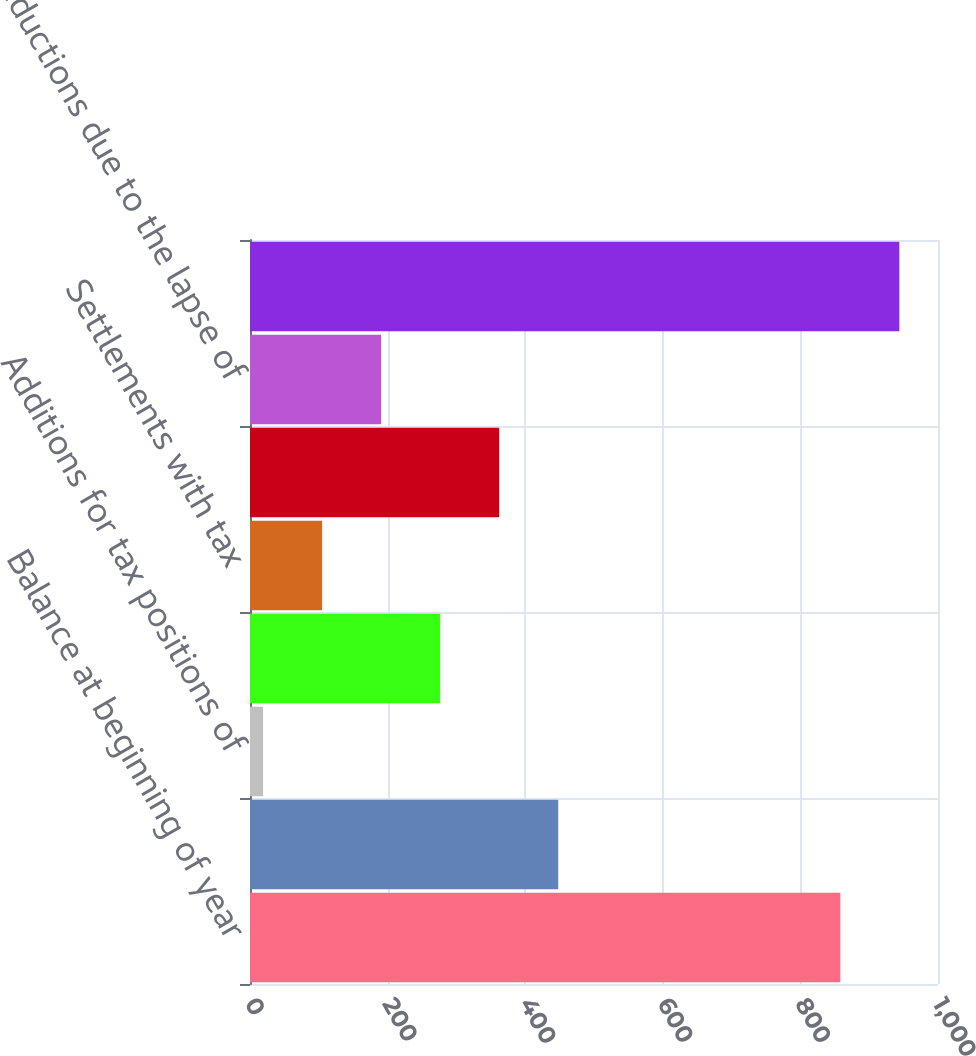Convert chart to OTSL. <chart><loc_0><loc_0><loc_500><loc_500><bar_chart><fcel>Balance at beginning of year<fcel>Additions based on tax<fcel>Additions for tax positions of<fcel>Impact of changes in exchange<fcel>Settlements with tax<fcel>Reductions for tax positions<fcel>Reductions due to the lapse of<fcel>Balance at end of year<nl><fcel>858<fcel>448<fcel>19<fcel>276.4<fcel>104.8<fcel>362.2<fcel>190.6<fcel>943.8<nl></chart> 